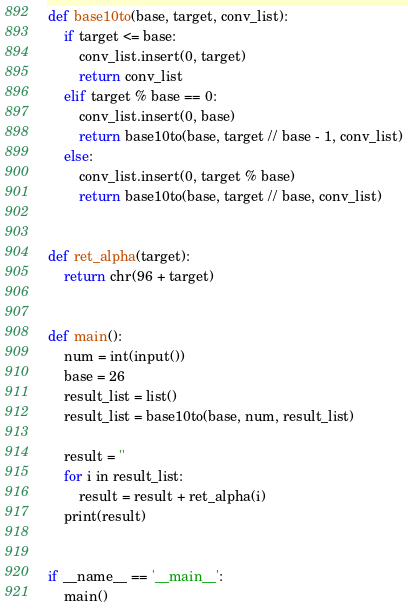<code> <loc_0><loc_0><loc_500><loc_500><_Python_>def base10to(base, target, conv_list):
    if target <= base:
        conv_list.insert(0, target)
        return conv_list
    elif target % base == 0:
        conv_list.insert(0, base)
        return base10to(base, target // base - 1, conv_list)
    else:
        conv_list.insert(0, target % base)
        return base10to(base, target // base, conv_list)


def ret_alpha(target):
    return chr(96 + target)


def main():
    num = int(input())
    base = 26
    result_list = list()
    result_list = base10to(base, num, result_list)

    result = ''
    for i in result_list:
        result = result + ret_alpha(i)
    print(result)


if __name__ == '__main__':
    main()
</code> 